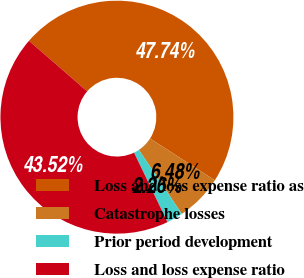Convert chart. <chart><loc_0><loc_0><loc_500><loc_500><pie_chart><fcel>Loss and loss expense ratio as<fcel>Catastrophe losses<fcel>Prior period development<fcel>Loss and loss expense ratio<nl><fcel>47.74%<fcel>6.48%<fcel>2.26%<fcel>43.52%<nl></chart> 